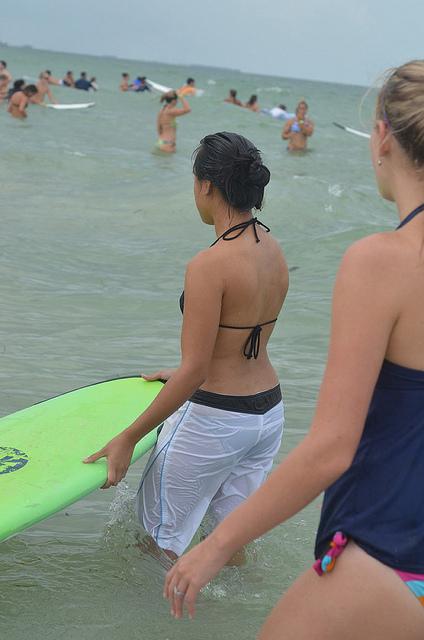What color is the surfboard?
Concise answer only. Green. What are these people riding in?
Give a very brief answer. Water. Are they the only ones surfing?
Be succinct. No. Is the woman wearing a bikini?
Quick response, please. Yes. What color is the swimsuit?
Give a very brief answer. Black. Are all the people surfing?
Answer briefly. No. 